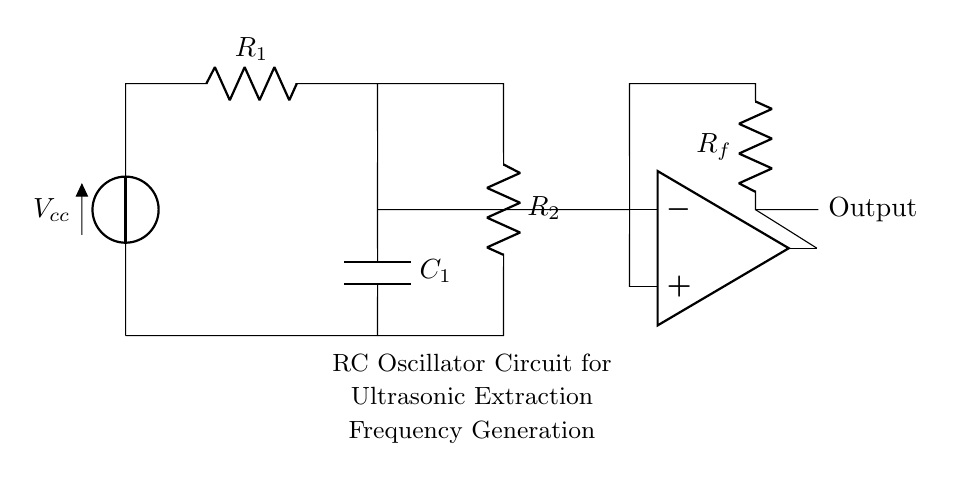What is the power supply voltage for this circuit? The circuit is powered by a voltage source labeled as Vcc, which is indicated at the top of the circuit diagram.
Answer: Vcc What type of capacitive component is present in the circuit? The circuit includes a capacitor labeled as C1, which is represented on the left side of the circuit. This identifies it as an essential part of the oscillator.
Answer: Capacitor What is the function of the op-amp in this circuit? The operational amplifier (op amp) is configured to amplify the voltage signal generated by the RC components, which aids in generating the desired oscillation frequency for ultrasonic extraction.
Answer: Amplification How many resistors are present in the circuit? There are two resistors labeled R1 and R2, which are positioned in the upper right section of the circuit diagram. Their configuration contributes to setting the oscillation frequency.
Answer: Two What is the relationship between the values of R and C in determining frequency? The frequency of the oscillation in an RC oscillator is inversely related to the product of resistance and capacitance, which can be expressed as frequency equals one divided by the product of R and C.
Answer: Inverse relationship What is the output from the op-amp labeled as? The output from the op-amp is simply labeled "Output" and is intended to indicate where the amplified signal is produced for further processing or application in ultrasonic extraction.
Answer: Output 